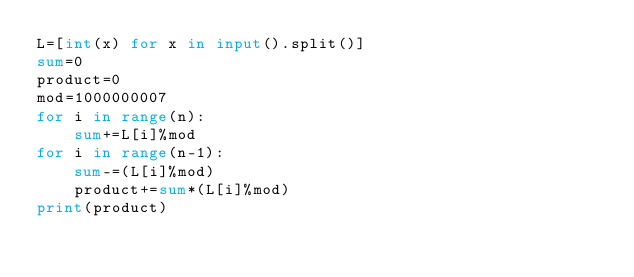Convert code to text. <code><loc_0><loc_0><loc_500><loc_500><_Python_>L=[int(x) for x in input().split()]
sum=0
product=0
mod=1000000007
for i in range(n):
    sum+=L[i]%mod
for i in range(n-1):
    sum-=(L[i]%mod)
    product+=sum*(L[i]%mod)
print(product)</code> 